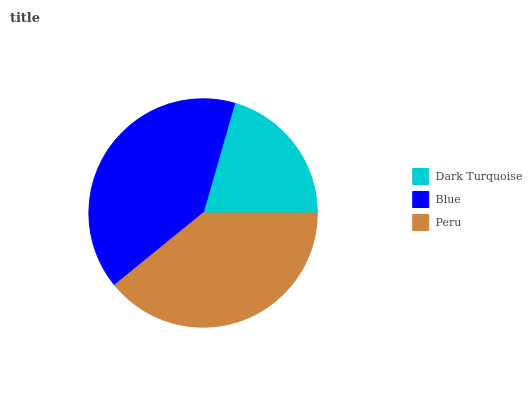Is Dark Turquoise the minimum?
Answer yes or no. Yes. Is Blue the maximum?
Answer yes or no. Yes. Is Peru the minimum?
Answer yes or no. No. Is Peru the maximum?
Answer yes or no. No. Is Blue greater than Peru?
Answer yes or no. Yes. Is Peru less than Blue?
Answer yes or no. Yes. Is Peru greater than Blue?
Answer yes or no. No. Is Blue less than Peru?
Answer yes or no. No. Is Peru the high median?
Answer yes or no. Yes. Is Peru the low median?
Answer yes or no. Yes. Is Dark Turquoise the high median?
Answer yes or no. No. Is Blue the low median?
Answer yes or no. No. 